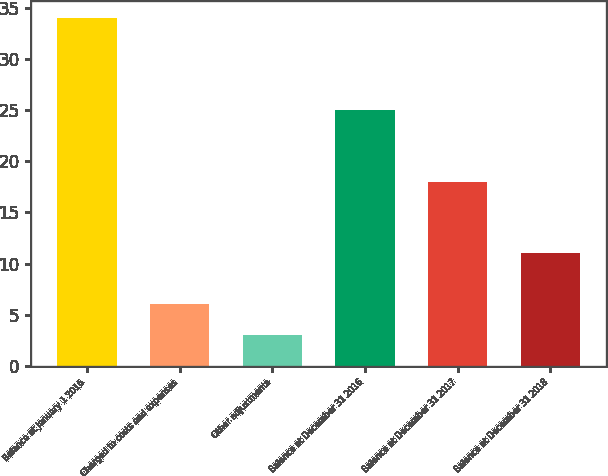<chart> <loc_0><loc_0><loc_500><loc_500><bar_chart><fcel>Balance at January 1 2016<fcel>Charged to costs and expenses<fcel>Other adjustments<fcel>Balance at December 31 2016<fcel>Balance at December 31 2017<fcel>Balance at December 31 2018<nl><fcel>34<fcel>6.1<fcel>3<fcel>25<fcel>18<fcel>11<nl></chart> 